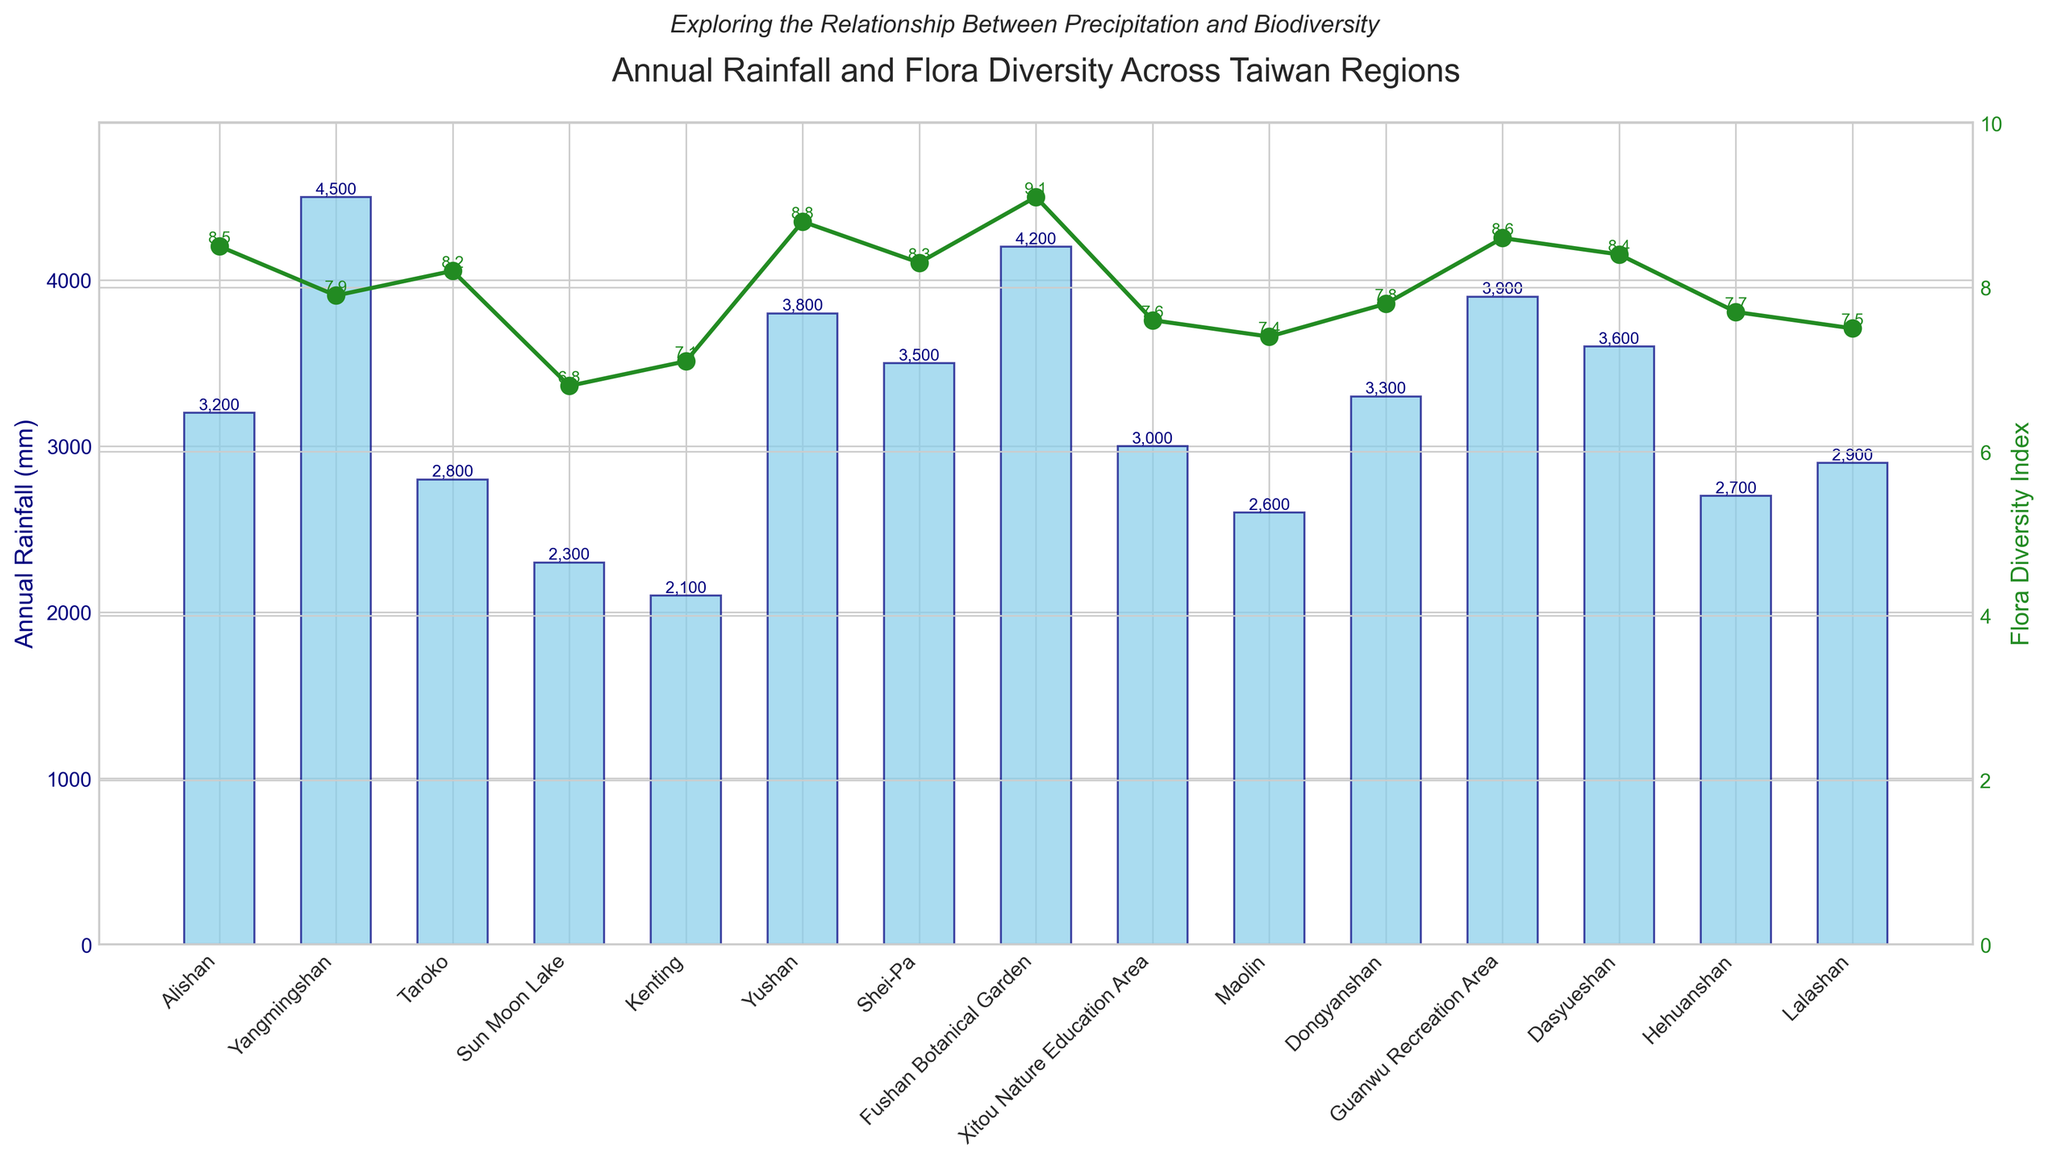Which region has the highest annual rainfall? The bar for Yangmingshan is the tallest, indicating the highest annual rainfall of 4500 mm among all regions.
Answer: Yangmingshan Which region has the lowest flora diversity index? The line graph shows that Sun Moon Lake has the lowest flora diversity index of 6.8 compared to other regions.
Answer: Sun Moon Lake What is the difference in annual rainfall between Yushan and Kenting? The annual rainfall for Yushan is 3800 mm, and for Kenting, it is 2100 mm. Subtract Kenting's rainfall from Yushan's, resulting in 3800 - 2100 = 1700 mm.
Answer: 1700 mm How does the flora diversity index of Fushan Botanical Garden compare to that of Maolin? The line for Fushan Botanical Garden is at 9.1 and for Maolin, it is at 7.4. Fushan Botanical Garden has a higher flora diversity index.
Answer: Fushan Botanical Garden has a higher flora diversity index Which region has both high annual rainfall and high flora diversity index? Both the bar chart and line graph show that Yushan has a high annual rainfall of 3800 mm and a high flora diversity index of 8.8.
Answer: Yushan What is the average flora diversity index of Dasyueshan, Hehuanshan, and Lalashan? Add the flora diversity indices: Dasyueshan (8.4), Hehuanshan (7.7), Lalashan (7.5). The sum is 8.4 + 7.7 + 7.5 = 23.6. Divide by 3 to get the average: 23.6 / 3 = 7.87.
Answer: 7.87 Which region shows a higher flora diversity index despite having lower annual rainfall, Taroko or Shei-Pa? The flora diversity index for Taroko is 8.2, and for Shei-Pa, it is 8.3. Despite Taroko having lower annual rainfall (2800 mm vs. 3500 mm for Shei-Pa), Shei-Pa has a slightly higher flora diversity index.
Answer: Shei-Pa What is the combined annual rainfall for Xitou Nature Education Area and Guanwu Recreation Area? The annual rainfall for Xitou Nature Education Area is 3000 mm, and for Guanwu Recreation Area, it's 3900 mm. Combined, it is 3000 + 3900 = 6900 mm.
Answer: 6900 mm 